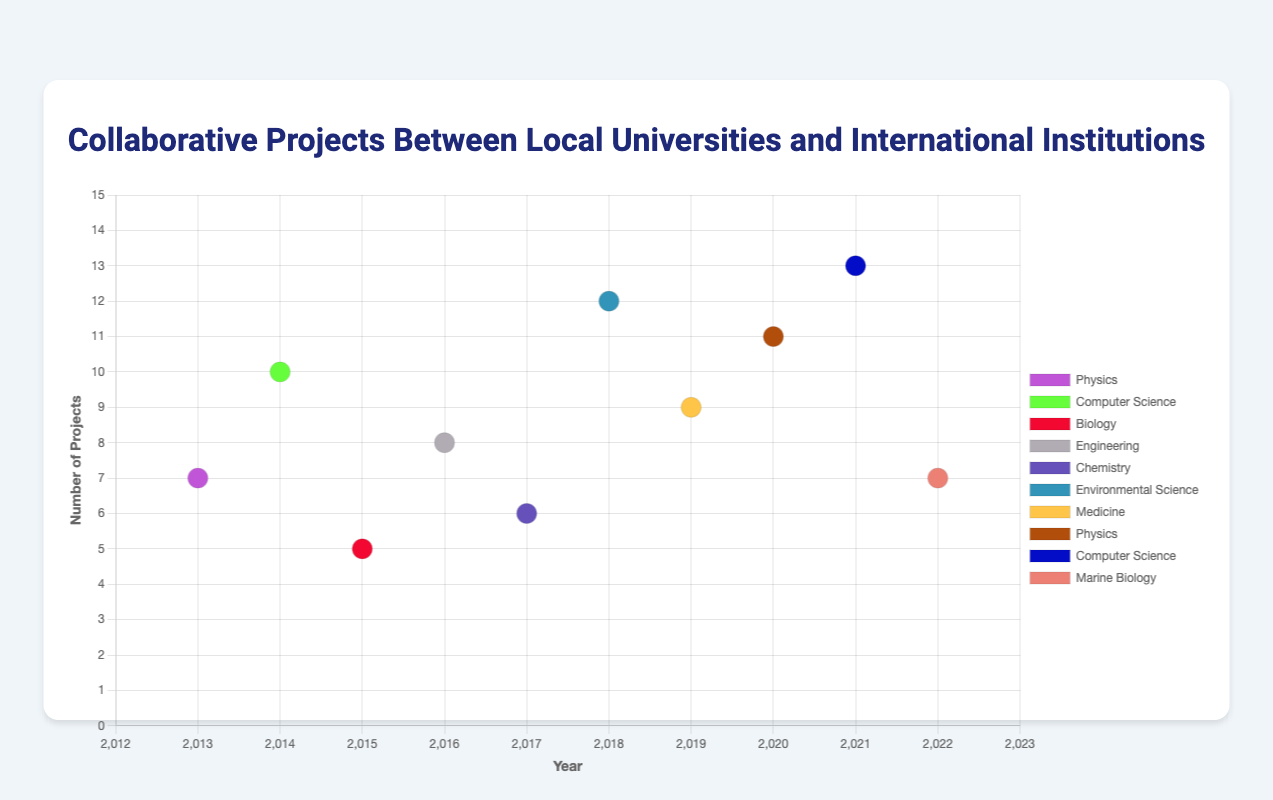Which research field had the highest number of collaborative projects in the most recent year? In 2022, the Marine Biology field had 7 collaborative projects, which was the highest number among the projects documented for that year.
Answer: Marine Biology Which local university had the most collaborative projects in 2020? There is only one local university listed in 2020, the University of California, Berkeley, with 11 collaborative projects.
Answer: University of California, Berkeley How many total collaborative projects were documented in 2014 across all research fields? In 2014, there was only one documented project in Computer Science with a total of 10 collaborative projects.
Answer: 10 Compare the number of collaborative projects between the University of California, Berkeley, and Stanford University in their respective fields for the years in which they are listed. Which university had more projects? University of California, Berkeley had 7 projects in Physics in 2013, 8 in Engineering in 2016, and 11 in Physics in 2020, totaling 26. Stanford University had 10 projects in Computer Science in 2014, 6 in Chemistry in 2017, and 13 in Computer Science in 2021, totaling 29.
Answer: Stanford University Which year saw the highest number of collaborative projects in the Physics research field? The Physics research field had the highest number of collaborative projects in 2020, with 11 projects.
Answer: 2020 What is the average number of collaborative projects across all research fields for the year 2018? In 2018, there was only one documented project in Environmental Science with 12 collaborative projects. Since there's only one value, the average is 12.
Answer: 12 Identify the fields that had collaborative projects in both the start and end of the decade. Physics had collaborative projects in both 2013 (7 projects) and 2020 (11 projects).
Answer: Physics What is the difference in the number of collaborative projects between the highest and lowest fields in 2019? In 2019, Medicine had 9 collaborative projects. It is the only field listed for that year, so the difference is 0.
Answer: 0 Which international institution collaborated with the University of Washington on the highest number of projects across all documented years? The University of Washington collaborated with the University of Tokyo in 2015 (5 projects) and Karolinska Institute in 2019 (9 projects). The highest number of projects was with Karolinska Institute.
Answer: Karolinska Institute 